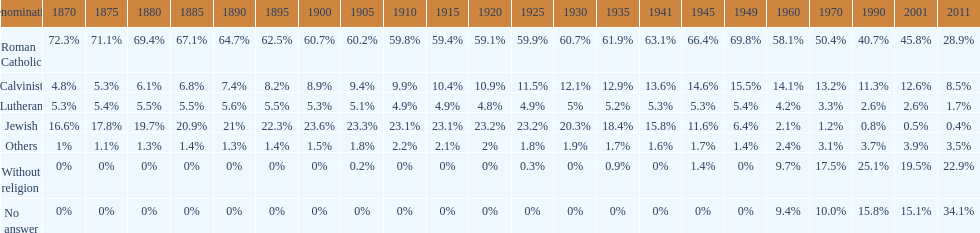What is the total percentage of people who identified as religious in 2011? 43%. 